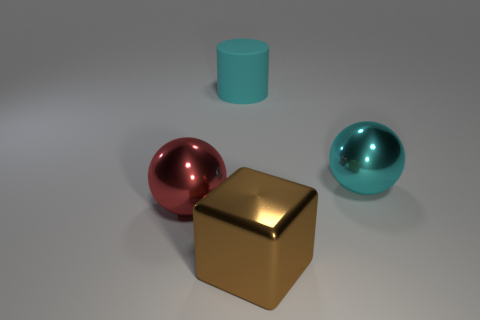There is a big cyan shiny object right of the red metallic ball; does it have the same shape as the metallic thing that is to the left of the big brown metallic block?
Your answer should be very brief. Yes. What material is the large red thing that is the same shape as the large cyan shiny thing?
Your answer should be compact. Metal. How many spheres are matte objects or large objects?
Give a very brief answer. 2. What number of large objects have the same material as the cyan sphere?
Your answer should be compact. 2. Is the big object right of the metallic block made of the same material as the thing in front of the big red metallic object?
Give a very brief answer. Yes. There is a sphere on the left side of the big cyan object that is in front of the cyan matte thing; how many large cyan matte cylinders are behind it?
Provide a short and direct response. 1. Do the big object that is behind the large cyan metal sphere and the large sphere that is on the right side of the cylinder have the same color?
Provide a short and direct response. Yes. Is there any other thing of the same color as the large block?
Give a very brief answer. No. There is a large thing behind the big cyan object that is on the right side of the rubber object; what color is it?
Your answer should be compact. Cyan. Are there any small gray metallic spheres?
Ensure brevity in your answer.  No. 